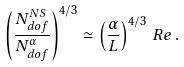Convert formula to latex. <formula><loc_0><loc_0><loc_500><loc_500>\left ( \frac { N _ { d o f } ^ { N S } } { N _ { d o f } ^ { \alpha } } \right ) ^ { 4 / 3 } \simeq \left ( \frac { \alpha } { L } \right ) ^ { 4 / 3 } \, R e \, .</formula> 